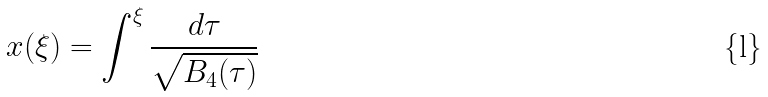Convert formula to latex. <formula><loc_0><loc_0><loc_500><loc_500>x ( \xi ) = \int ^ { \xi } \frac { d \tau } { \sqrt { B _ { 4 } ( \tau ) } }</formula> 